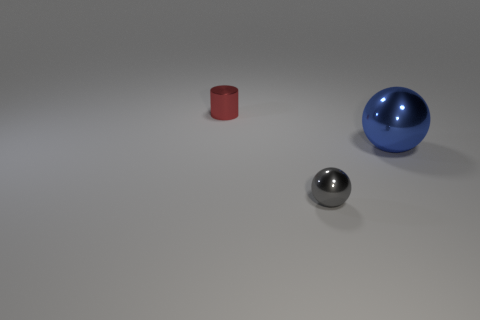Add 1 tiny purple rubber balls. How many objects exist? 4 Subtract all spheres. How many objects are left? 1 Subtract 0 cyan spheres. How many objects are left? 3 Subtract all metal blocks. Subtract all small gray metallic spheres. How many objects are left? 2 Add 3 gray metallic spheres. How many gray metallic spheres are left? 4 Add 2 red metallic cylinders. How many red metallic cylinders exist? 3 